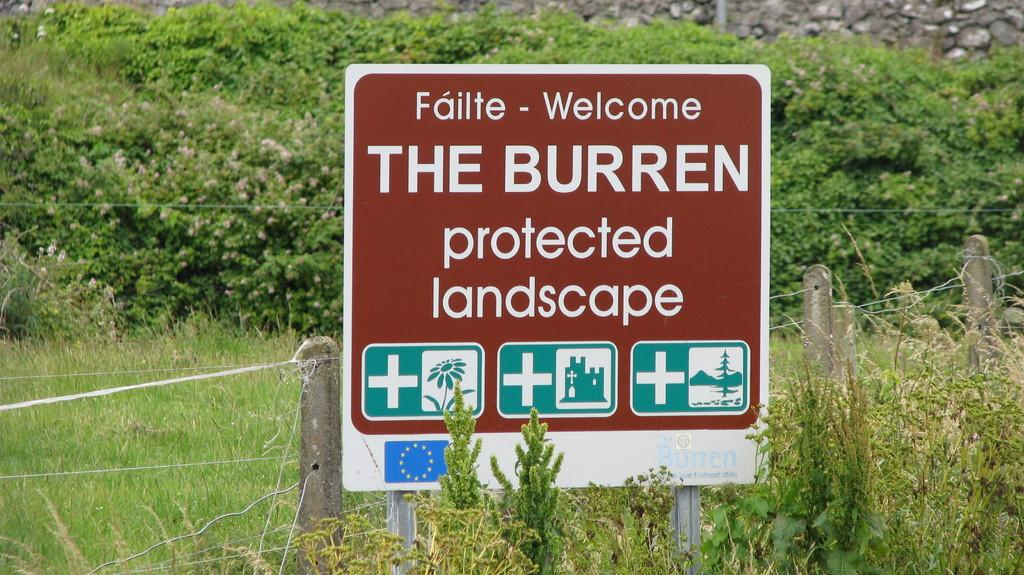Provide a one-sentence caption for the provided image. An outdoor sign with the words Welcome and The Burren protected landscape on it. 